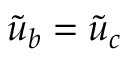<formula> <loc_0><loc_0><loc_500><loc_500>\tilde { u } _ { b } = \tilde { u } _ { c }</formula> 